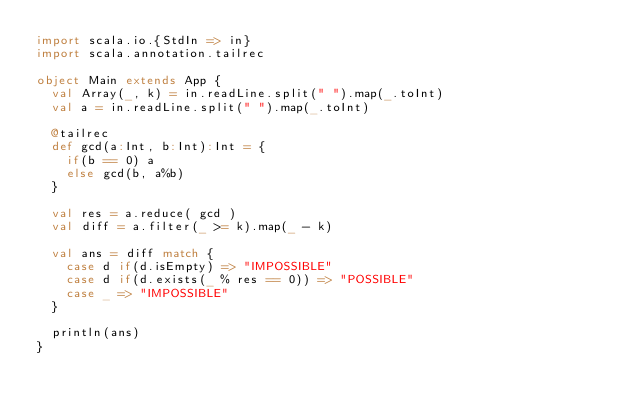<code> <loc_0><loc_0><loc_500><loc_500><_Scala_>import scala.io.{StdIn => in}
import scala.annotation.tailrec

object Main extends App {
  val Array(_, k) = in.readLine.split(" ").map(_.toInt)
  val a = in.readLine.split(" ").map(_.toInt)
  
  @tailrec
  def gcd(a:Int, b:Int):Int = {
    if(b == 0) a
    else gcd(b, a%b)
  }

  val res = a.reduce( gcd )
  val diff = a.filter(_ >= k).map(_ - k)

  val ans = diff match {
    case d if(d.isEmpty) => "IMPOSSIBLE"
    case d if(d.exists(_ % res == 0)) => "POSSIBLE"
    case _ => "IMPOSSIBLE"
  }

  println(ans)
}</code> 